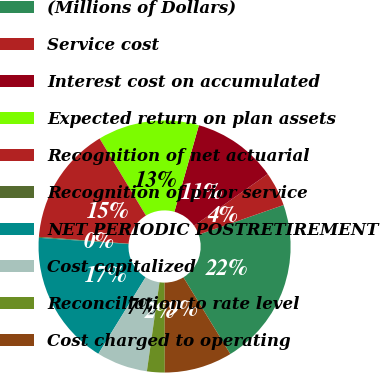Convert chart. <chart><loc_0><loc_0><loc_500><loc_500><pie_chart><fcel>(Millions of Dollars)<fcel>Service cost<fcel>Interest cost on accumulated<fcel>Expected return on plan assets<fcel>Recognition of net actuarial<fcel>Recognition of prior service<fcel>NET PERIODIC POSTRETIREMENT<fcel>Cost capitalized<fcel>Reconciliation to rate level<fcel>Cost charged to operating<nl><fcel>21.6%<fcel>4.41%<fcel>10.86%<fcel>13.01%<fcel>15.16%<fcel>0.12%<fcel>17.3%<fcel>6.56%<fcel>2.27%<fcel>8.71%<nl></chart> 